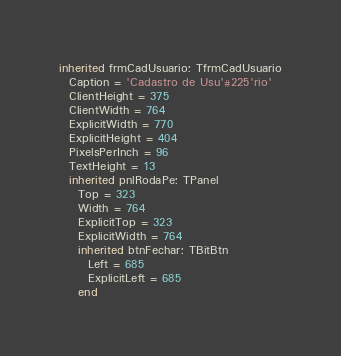<code> <loc_0><loc_0><loc_500><loc_500><_Pascal_>inherited frmCadUsuario: TfrmCadUsuario
  Caption = 'Cadastro de Usu'#225'rio'
  ClientHeight = 375
  ClientWidth = 764
  ExplicitWidth = 770
  ExplicitHeight = 404
  PixelsPerInch = 96
  TextHeight = 13
  inherited pnlRodaPe: TPanel
    Top = 323
    Width = 764
    ExplicitTop = 323
    ExplicitWidth = 764
    inherited btnFechar: TBitBtn
      Left = 685
      ExplicitLeft = 685
    end</code> 